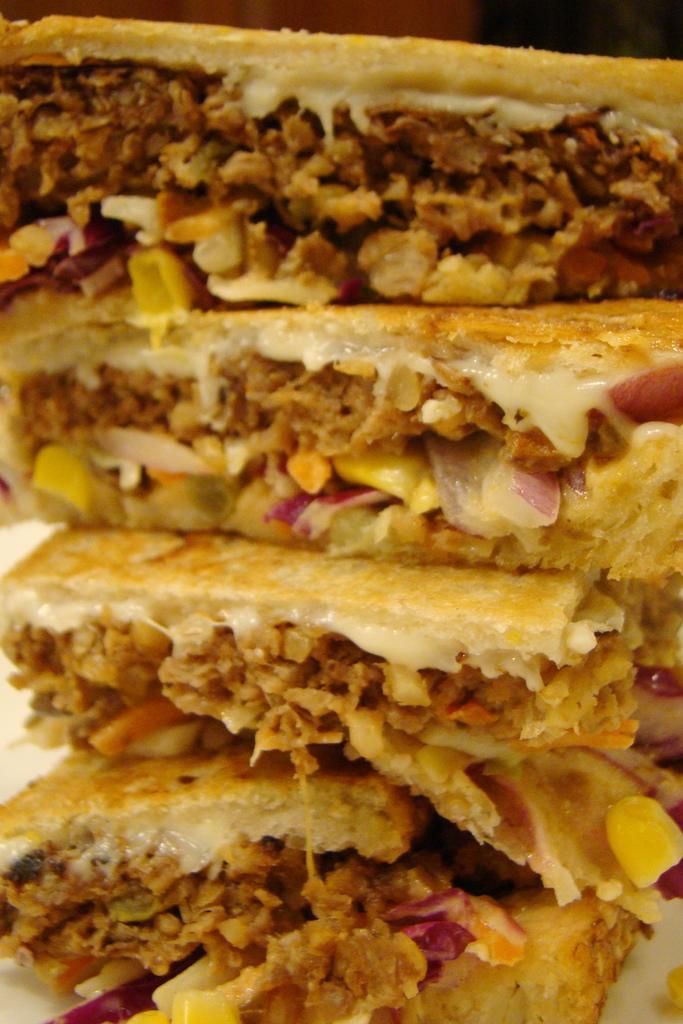In one or two sentences, can you explain what this image depicts? This image consists of sandwiches along with stuffings are kept in a plate. 